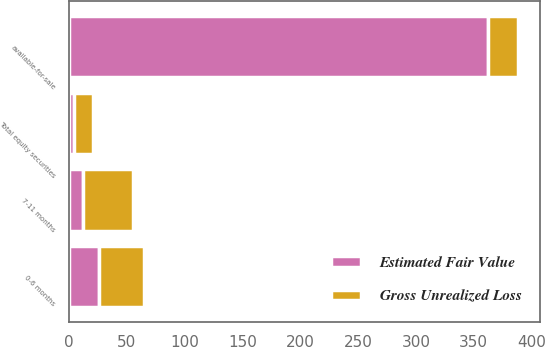<chart> <loc_0><loc_0><loc_500><loc_500><stacked_bar_chart><ecel><fcel>0-6 months<fcel>7-11 months<fcel>available-for-sale<fcel>Total equity securities<nl><fcel>Gross Unrealized Loss<fcel>39<fcel>43<fcel>26<fcel>17<nl><fcel>Estimated Fair Value<fcel>26<fcel>12<fcel>362<fcel>4<nl></chart> 